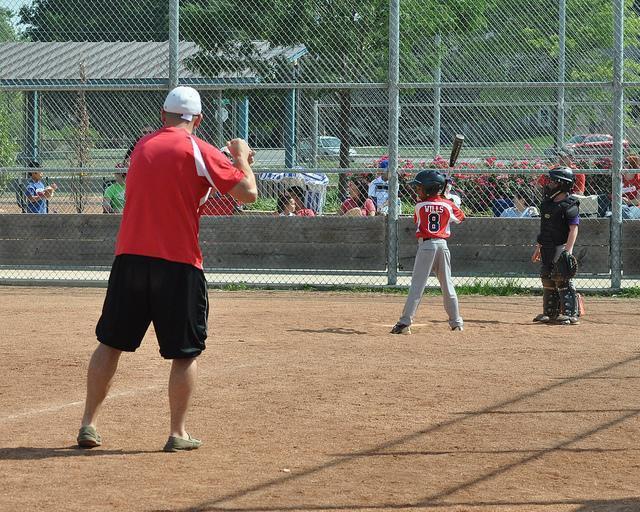How many people are visible?
Give a very brief answer. 3. 